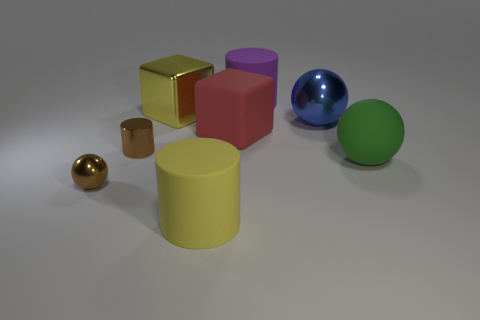Add 2 tiny red matte things. How many objects exist? 10 Subtract all cylinders. How many objects are left? 5 Subtract all brown spheres. Subtract all large yellow cylinders. How many objects are left? 6 Add 5 spheres. How many spheres are left? 8 Add 3 blue balls. How many blue balls exist? 4 Subtract 0 cyan cylinders. How many objects are left? 8 